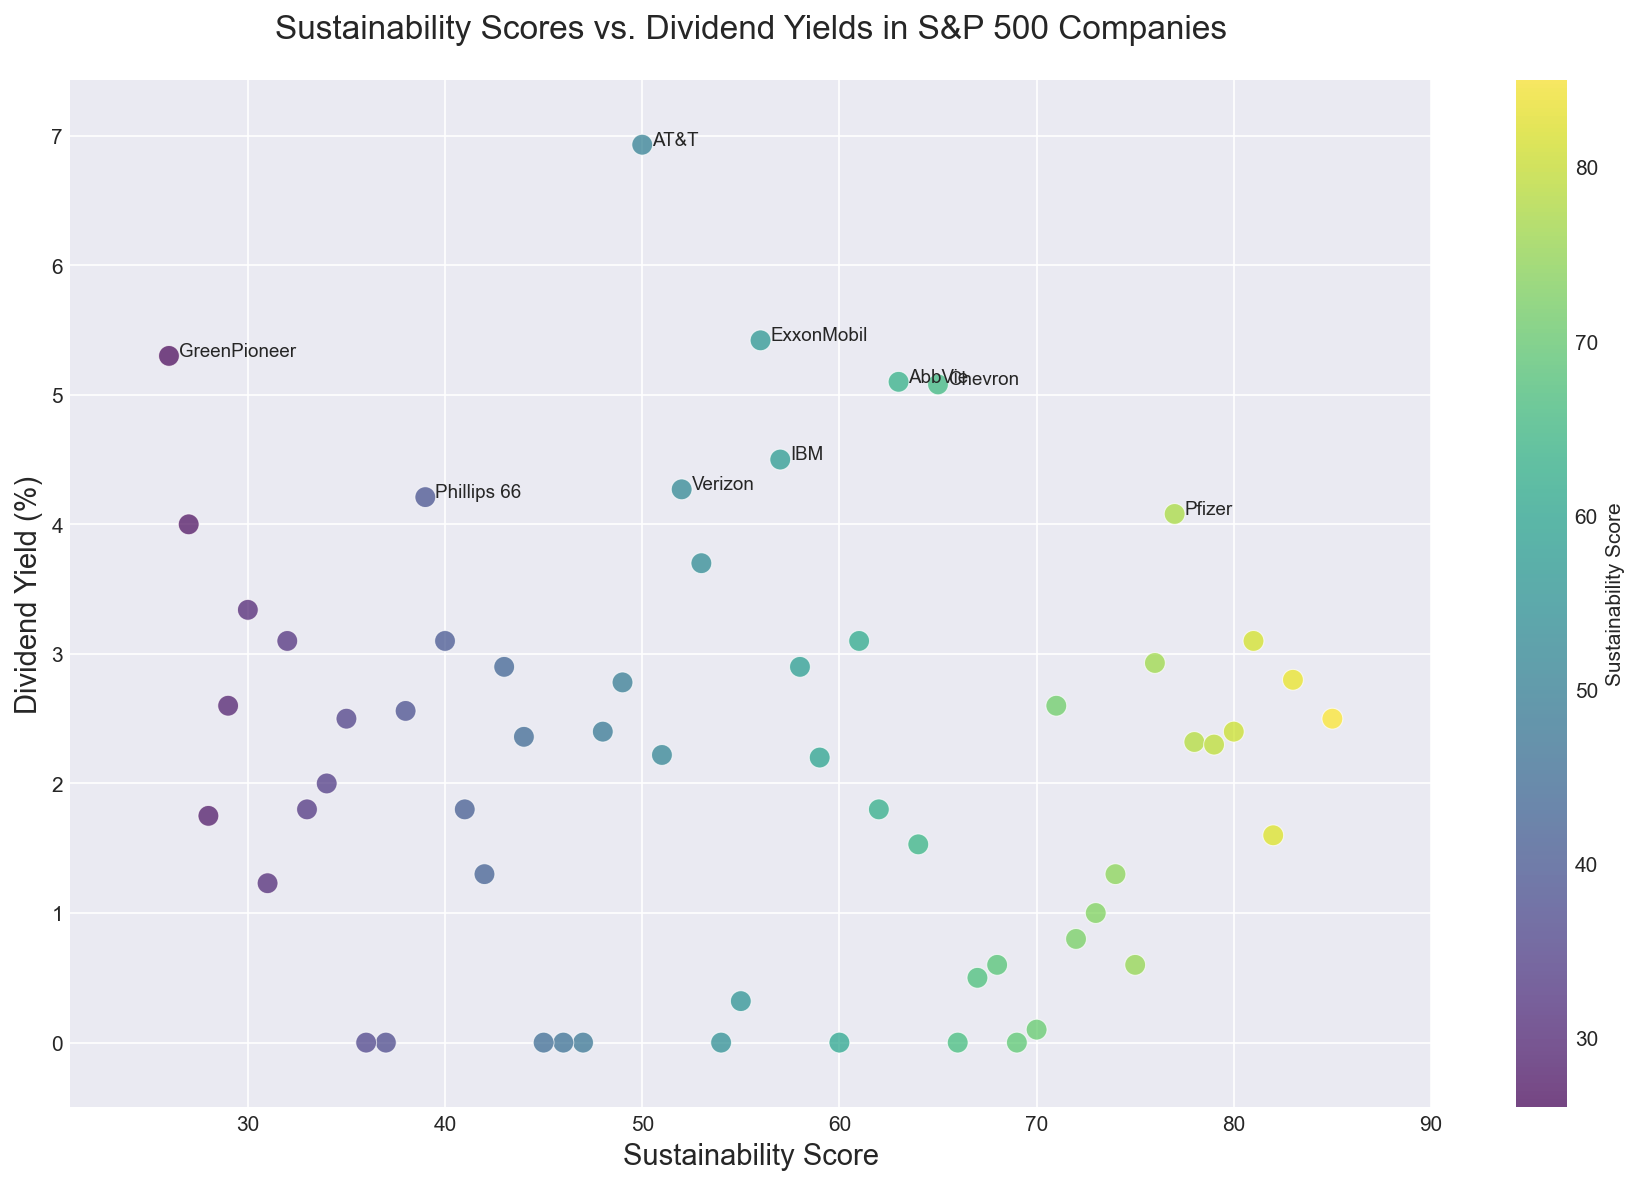What is the range of Sustainability Scores for companies with a Dividend Yield greater than 4%? Looking at the data points with Dividend Yield greater than 4%, identify the corresponding Sustainability Scores. These companies are Chevron (65), IBM (57), ExxonMobil (56), AbbVie (63), AT&T (50), Verizon (52), and GreenPioneer (26). The range is the difference between the maximum and minimum Sustainability Scores in this subset. Thus, the range is 65 - 26.
Answer: 39 Which company has the highest Dividend Yield, and what is its Sustainability Score? The company with the highest Dividend Yield will be the point highest on the y-axis. According to the data, AT&T has the highest Dividend Yield at 6.93%. Looking further, AT&T's Sustainability Score is 50.
Answer: AT&T, 50 Are there any companies with a Sustainability Score above 80 and a Dividend Yield above 2%? Locate the points on the scatter plot with a Sustainability Score above 80 and then check if any of these points have a Dividend Yield above 2%. The companies with Sustainability Scores above 80 are Johnson & Johnson (85), Procter & Gamble (80), and Walmart (82). Among these, none of the companies have a Dividend Yield above 2%.
Answer: No What is the average Dividend Yield for companies with Sustainability Scores below 40? Identify the companies with Sustainability Scores below 40: FutureFinance (29, 2.60), SavvyInvest (28, 1.75), EcoEnterprise (27, 4.00), GreenPioneer (26, 5.30), MoreDataInc (34, 2.00), AnotherCorp (33, 1.80), YetAnotherCo (32, 3.10), EndeavorLtd (31, 1.23), BetterBusiness (30, 3.34), T-Mobile (37, 0), Berkshire Hathaway (36, 0), Aflac (35, 2.50). The average Dividend Yield for these companies is the sum of their Dividend Yields divided by the number of such companies. Calculation: (2.60 + 1.75 + 4.00 + 5.30 + 2.00 + 1.80 + 3.10 + 1.23 + 3.34 + 0 + 0 + 2.50) / 12 = 27.62 / 12.
Answer: 2.30 Which companies have a Dividend Yield of 0%, and what are their Sustainability Scores? Identify the data points on the scatter plot with a Dividend Yield of 0%, then list their corresponding Sustainability Scores. According to the data, the companies are PayPal (69), Tesla (66), Facebook (54), Boeing (60), and T-Mobile (37), with scores of 69, 66, 54, 60, and 37 respectively.
Answer: PayPal (69), Tesla (66), Facebook (54), Boeing (60), T-Mobile (37) Is there a discernible trend between Sustainability Score and Dividend Yield? Observe the general distribution and gradient of points across the scatter plot. The points appear scattered without a clear linear or exponential pattern, indicating that no strong relationship or trend is visually evident between Sustainability Score and Dividend Yield.
Answer: No Which company has the lowest Sustainability Score and what is its Dividend Yield? Identify the data point with the lowest Sustainability Score on the scatter plot. According to the data, UnitedHealth Group has the lowest Sustainability Score at 42, and its Dividend Yield is indicated in the data as 1.30%.
Answer: UnitedHealth Group, 1.30 